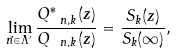<formula> <loc_0><loc_0><loc_500><loc_500>\lim _ { \vec { n } \in \Lambda ^ { \prime } } \frac { Q ^ { * } _ { \ n , k } ( z ) } { Q _ { \ n , k } ( z ) } = \frac { S _ { k } ( z ) } { S _ { k } ( \infty ) } ,</formula> 